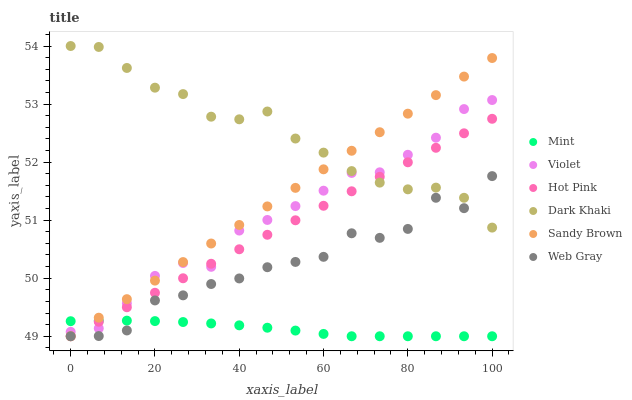Does Mint have the minimum area under the curve?
Answer yes or no. Yes. Does Dark Khaki have the maximum area under the curve?
Answer yes or no. Yes. Does Hot Pink have the minimum area under the curve?
Answer yes or no. No. Does Hot Pink have the maximum area under the curve?
Answer yes or no. No. Is Sandy Brown the smoothest?
Answer yes or no. Yes. Is Web Gray the roughest?
Answer yes or no. Yes. Is Mint the smoothest?
Answer yes or no. No. Is Mint the roughest?
Answer yes or no. No. Does Web Gray have the lowest value?
Answer yes or no. Yes. Does Dark Khaki have the lowest value?
Answer yes or no. No. Does Dark Khaki have the highest value?
Answer yes or no. Yes. Does Hot Pink have the highest value?
Answer yes or no. No. Is Mint less than Dark Khaki?
Answer yes or no. Yes. Is Violet greater than Web Gray?
Answer yes or no. Yes. Does Mint intersect Violet?
Answer yes or no. Yes. Is Mint less than Violet?
Answer yes or no. No. Is Mint greater than Violet?
Answer yes or no. No. Does Mint intersect Dark Khaki?
Answer yes or no. No. 